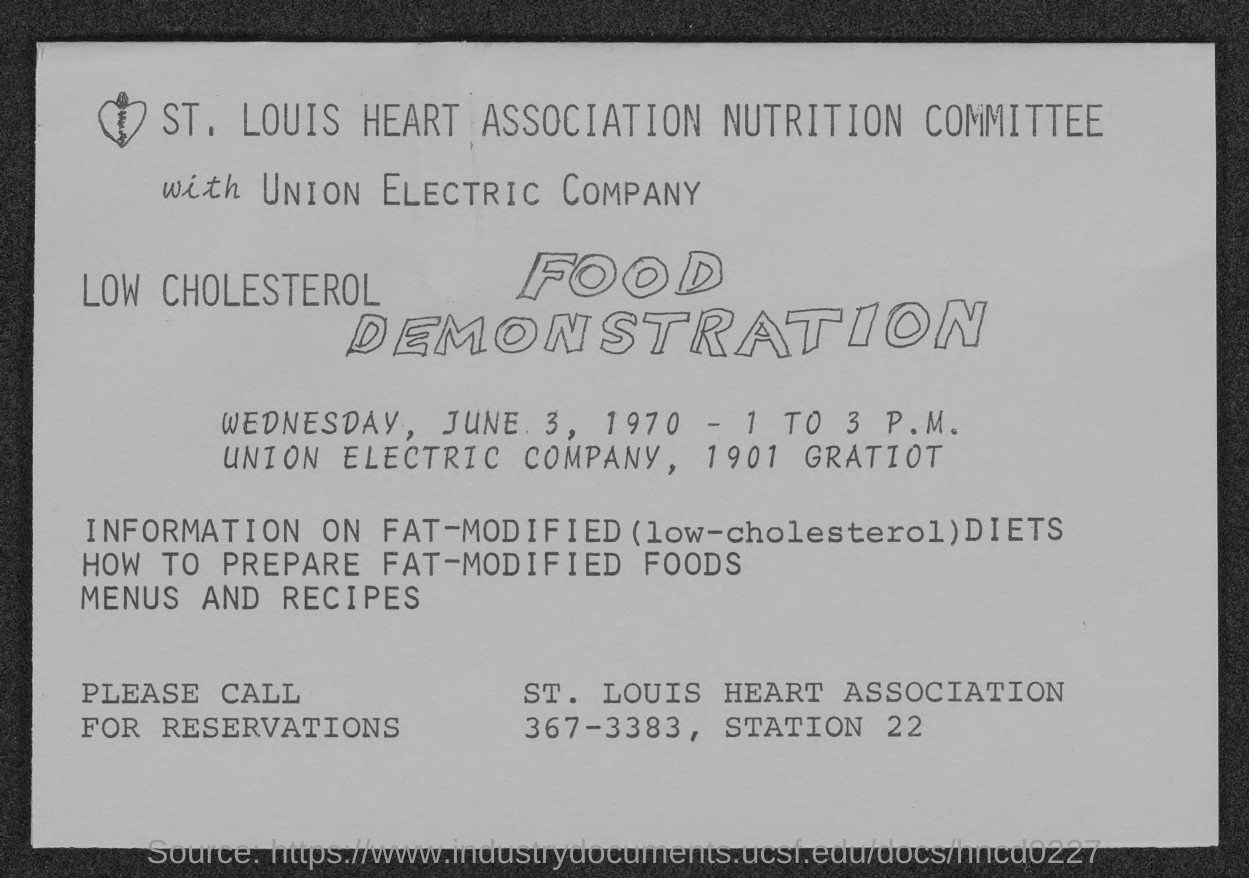Indicate a few pertinent items in this graphic. The name of the electric company is Union Electric Company. The street address of Union Electric Company is 1901 Gratiot. The St. Louis Heart Association Nutrition Committee is the name of a nutrition committee. The contact number of the St. Louis Heart Association is 367-3383. 